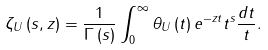<formula> <loc_0><loc_0><loc_500><loc_500>\zeta _ { U } \left ( s , z \right ) = \frac { 1 } { \Gamma \left ( s \right ) } \int _ { 0 } ^ { \infty } \theta _ { U } \left ( t \right ) e ^ { - z t } t ^ { s } \frac { d t } { t } .</formula> 